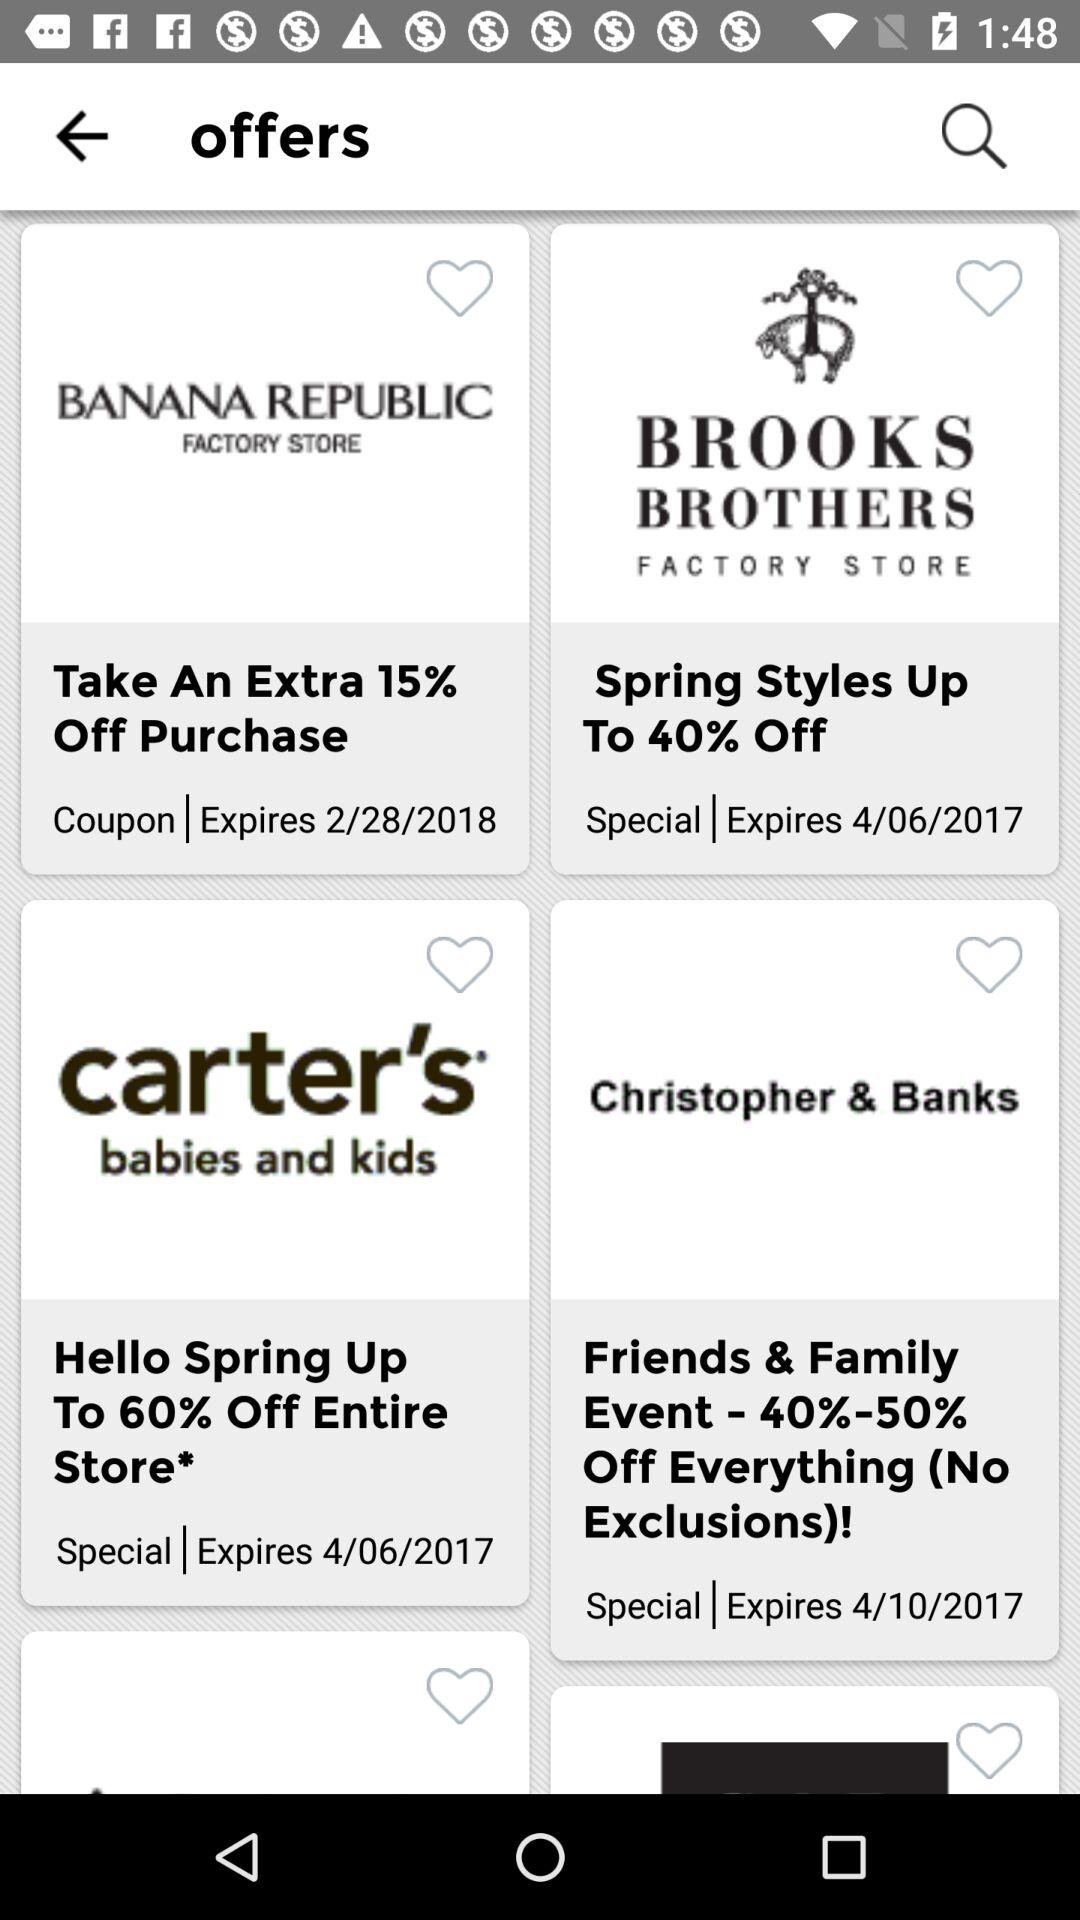How much of a percent is off at "Banana Republic"? At "Banana Republic," there is 15 percent off. 